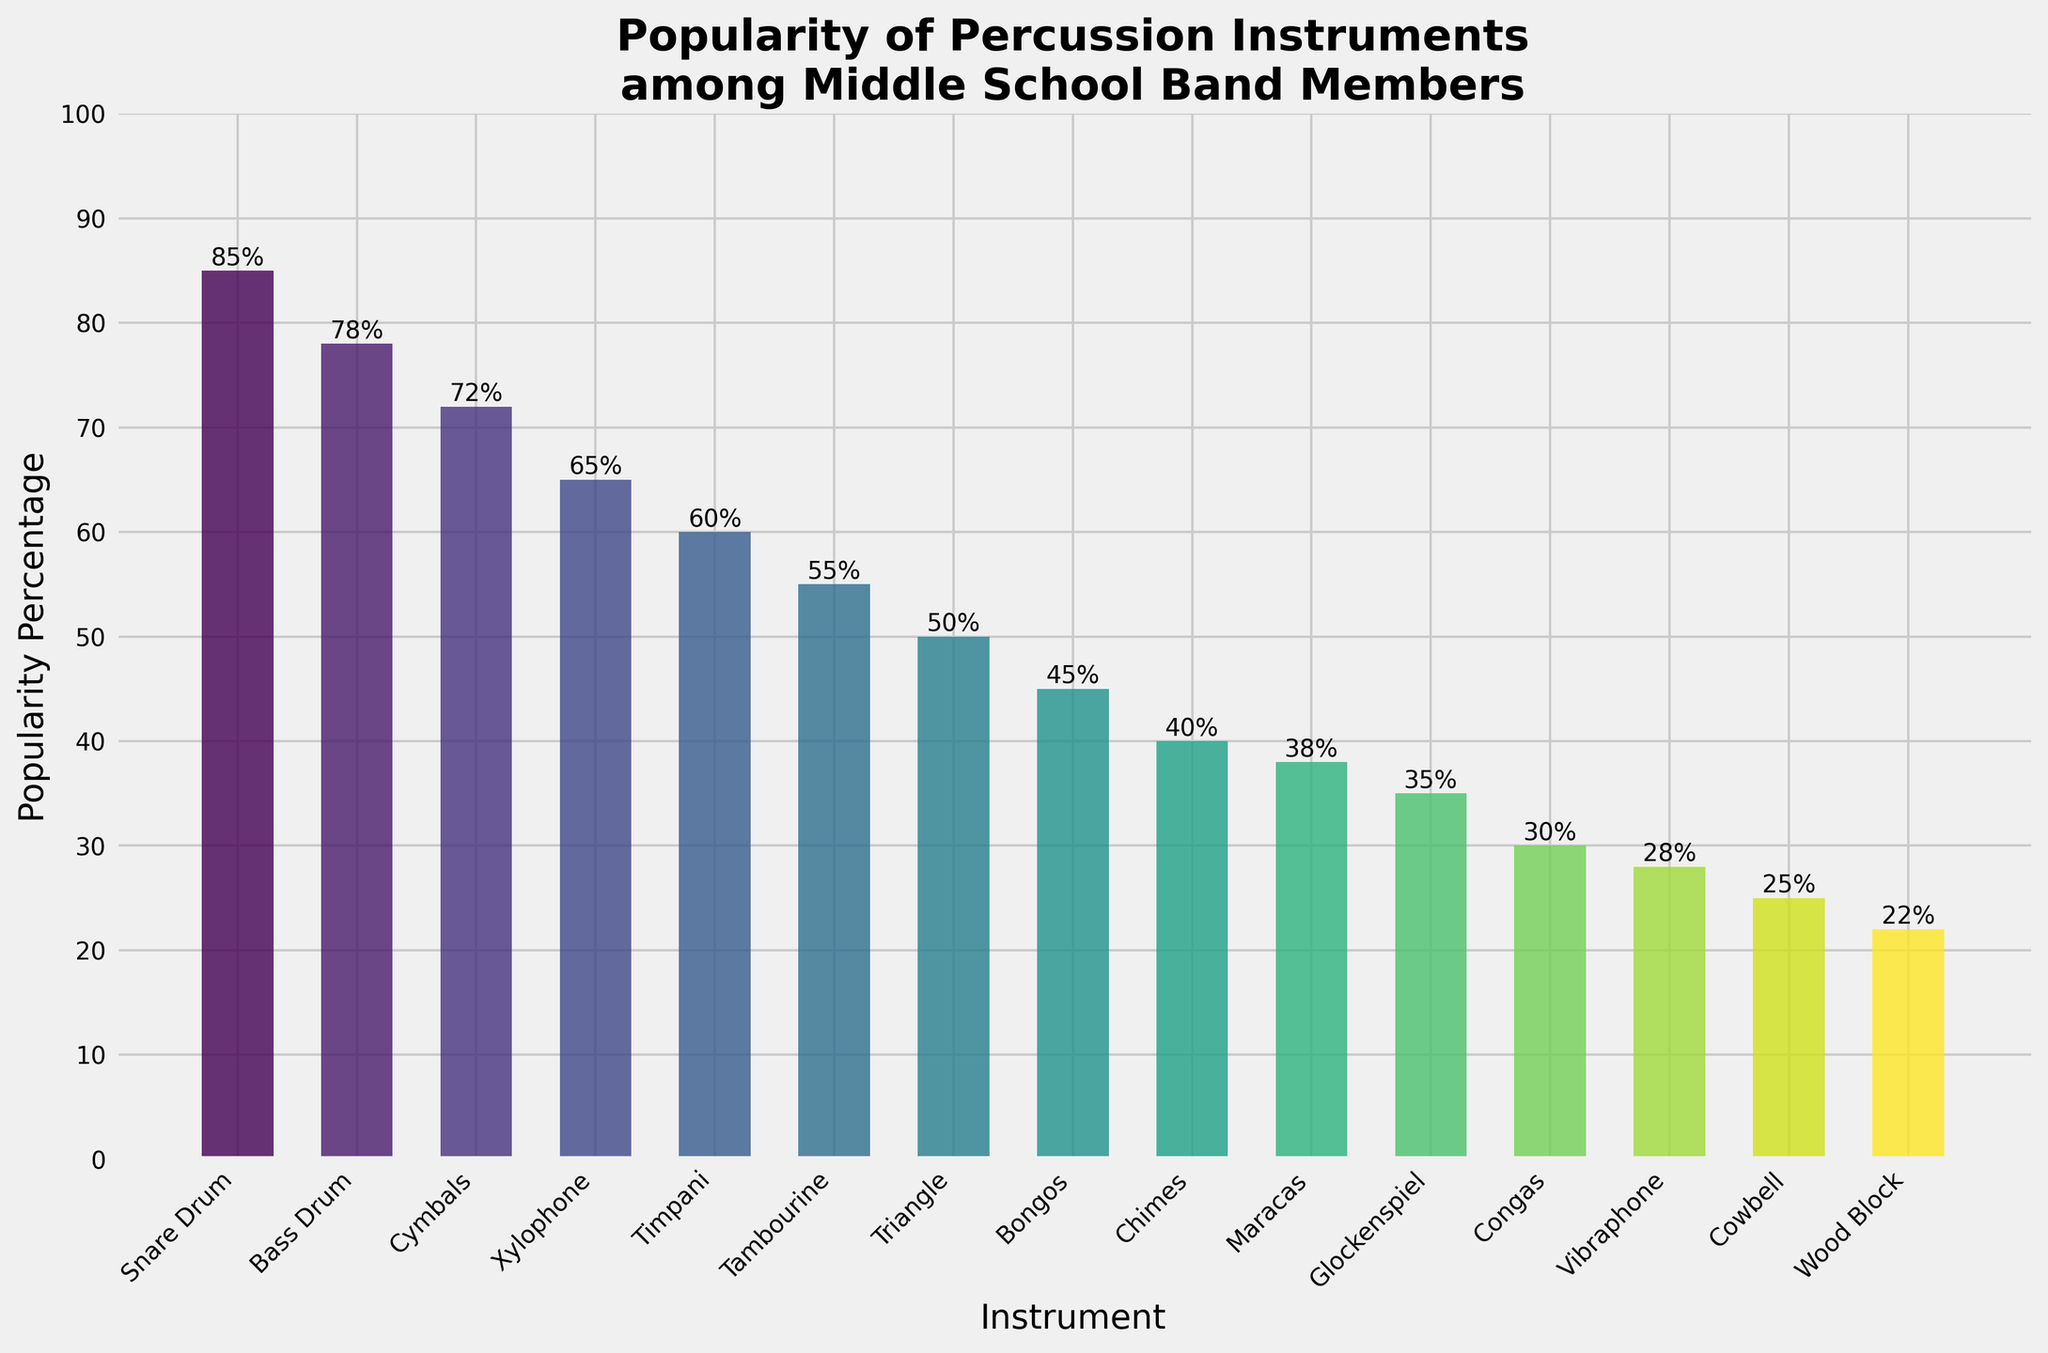What's the least popular percussion instrument among middle school band members? Look for the smallest bar in terms of height or the lowest value on the y-axis. The bar for Wood Block is the shortest with a popularity percentage of 22%.
Answer: Wood Block Which instrument has a higher popularity percentage: Glockenspiel or Maracas? Compare the heights of the bars for Glockenspiel and Maracas. The Glockenspiel has a popularity percentage of 35%, while Maracas have 38%.
Answer: Maracas How many instruments have a popularity percentage above 70%? Count the number of bars that exceed the 70% mark on the y-axis. Snare Drum, Bass Drum, and Cymbals all have percentages above 70%.
Answer: 3 What is the total popularity percentage for Snare Drum and Bass Drum combined? Add the popularity percentages of Snare Drum (85%) and Bass Drum (78%). 85 + 78 = 163
Answer: 163% Which instrument has a popularity percentage closest to 50%? Find the bar nearest to the 50% mark on the y-axis. The Tambourine is closest with a popularity percentage of 55%.
Answer: Tambourine By how much is the popularity of Congas lower than that of Bongos? Subtract the popularity percentage of Congas (30%) from Bongos (45%). 45 - 30 = 15
Answer: 15% What's the average popularity percentage of the instruments with percentages over 60%? Identify and sum the percentages over 60%: Snare Drum (85), Bass Drum (78), Cymbals (72), Xylophone (65), and Timpani (60). Calculate the average: (85 + 78 + 72 + 65 + 60)/5 = 72
Answer: 72% Which instrument's bar is green in the bar chart? Identify the color gradient used in the bar chart; green typically appears roughly in the middle. Xylophone has an intermediate popularity percentage, making its bar green.
Answer: Xylophone Are there more instruments with a popularity percentage above 50% or below 50%? Count the number of bars above and below the 50% mark: Above 50%: 6 instruments; Below 50%: 9 instruments.
Answer: Below 50% Which is more popular, the Triangle or the Chimes? Compare the heights of the bars for Triangle and Chimes. Triangle has a 50% popularity, while Chimes have 40%.
Answer: Triangle 